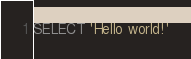Convert code to text. <code><loc_0><loc_0><loc_500><loc_500><_SQL_>SELECT 'Hello world!'
</code> 